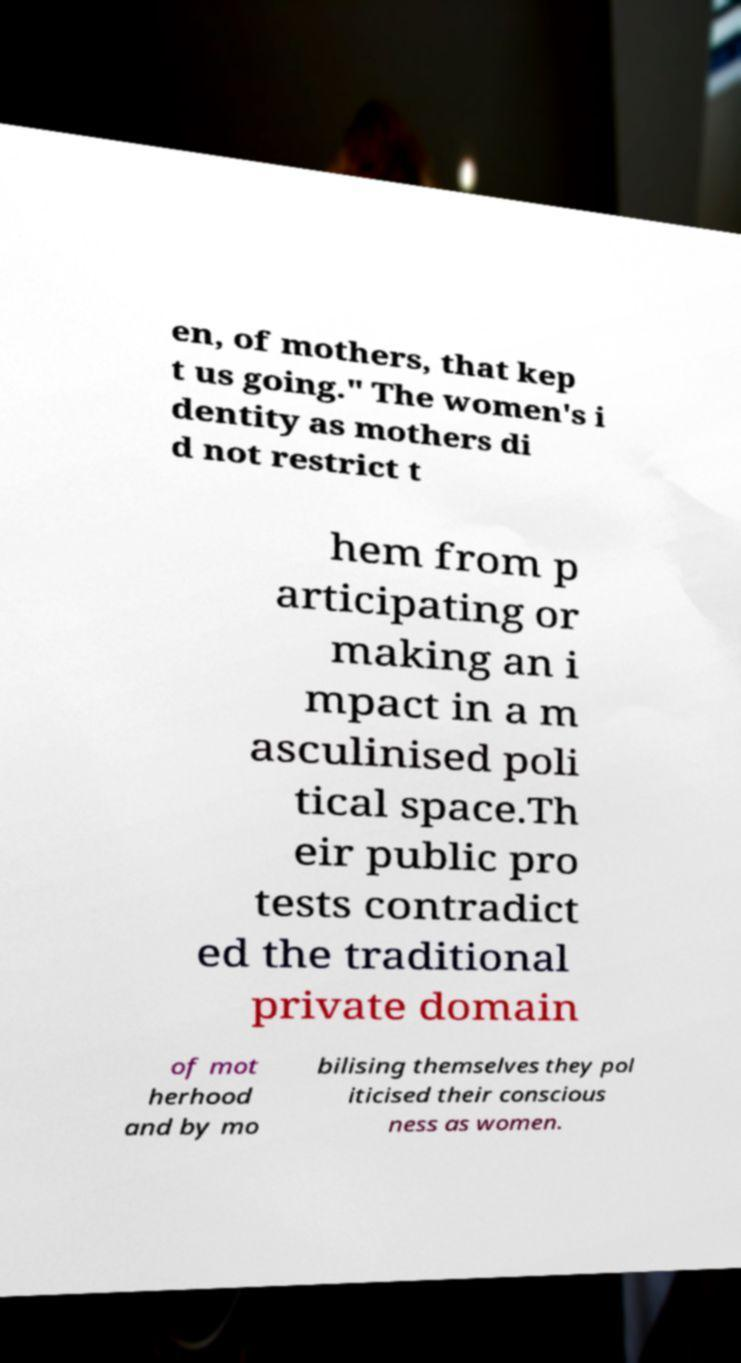What messages or text are displayed in this image? I need them in a readable, typed format. en, of mothers, that kep t us going." The women's i dentity as mothers di d not restrict t hem from p articipating or making an i mpact in a m asculinised poli tical space.Th eir public pro tests contradict ed the traditional private domain of mot herhood and by mo bilising themselves they pol iticised their conscious ness as women. 